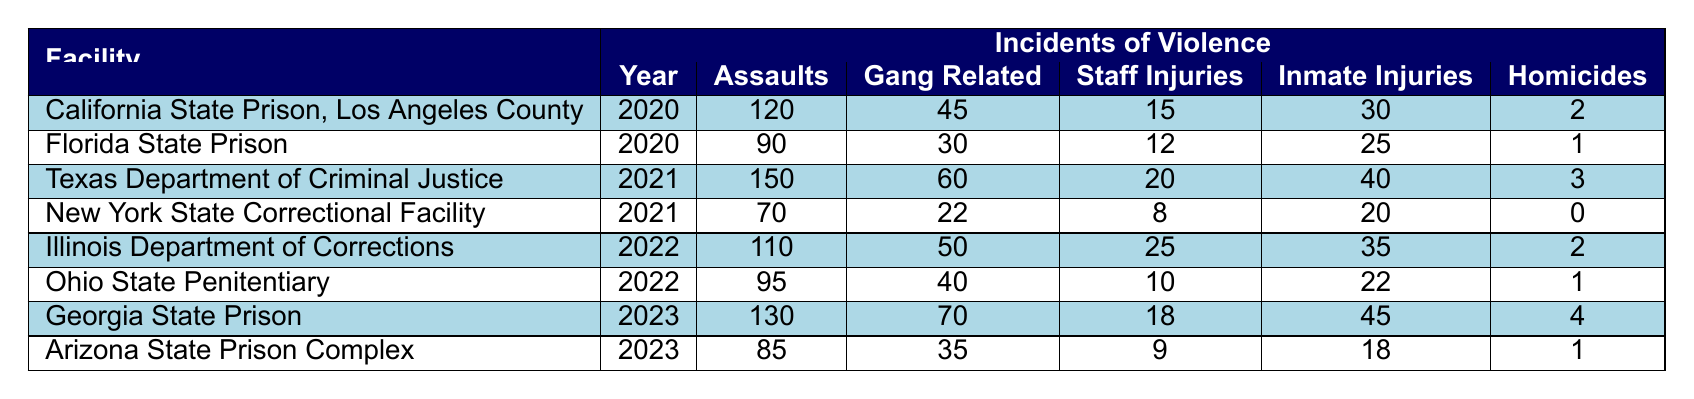What is the total number of assaults reported in Georgia State Prison in 2023? According to the table, Georgia State Prison reported 130 assaults in the year 2023.
Answer: 130 How many gang-related incidents occurred in California State Prison, Los Angeles County in 2020? The table indicates that there were 45 gang-related incidents in California State Prison, Los Angeles County in 2020.
Answer: 45 Is it true that New York State Correctional Facility reported any homicides in 2021? The table shows that New York State Correctional Facility reported 0 homicides in 2021, therefore the statement is true.
Answer: No What is the difference in the number of staff injuries reported between Texas Department of Criminal Justice in 2021 and Illinois Department of Corrections in 2022? The Texas Department of Criminal Justice reported 20 staff injuries in 2021, and the Illinois Department of Corrections reported 25 staff injuries in 2022. The difference is calculated as 25 - 20 = 5.
Answer: 5 Which facility had the highest number of inmate injuries in 2023, and how many were reported? In 2023, Georgia State Prison had the highest number of inmate injuries at 45, compared to Arizona State Prison Complex which reported 18.
Answer: Georgia State Prison, 45 What is the average number of assaults reported across all facilities in 2022? The assaults reported for 2022 are 110 in Illinois Department of Corrections and 95 in Ohio State Penitentiary. The sum is 110 + 95 = 205. There are 2 facilities, so the average is 205 / 2 = 102.5.
Answer: 102.5 In which year did Texas Department of Criminal Justice report the highest number of gang-related incidents? According to the table, Texas Department of Criminal Justice reported the highest number of gang-related incidents (60) in the year 2021.
Answer: 2021 Are there more staff injuries reported in 2023 than in 2020? In 2020, the total staff injuries were 15 (California) + 12 (Florida) = 27, while in 2023, they are 18 (Georgia) + 9 (Arizona) = 27. Therefore, there are not more staff injuries in 2023 as both years reported the same number.
Answer: No What facility had the least number of assaults in 2021? In 2021, New York State Correctional Facility reported 70 assaults, which is fewer than Texas Department of Criminal Justice that reported 150. Hence, New York had the least.
Answer: New York State Correctional Facility, 70 